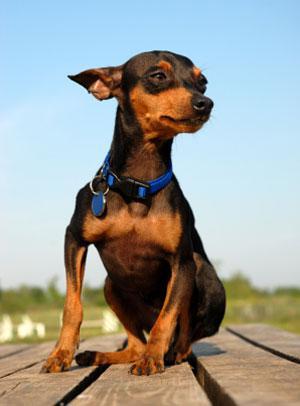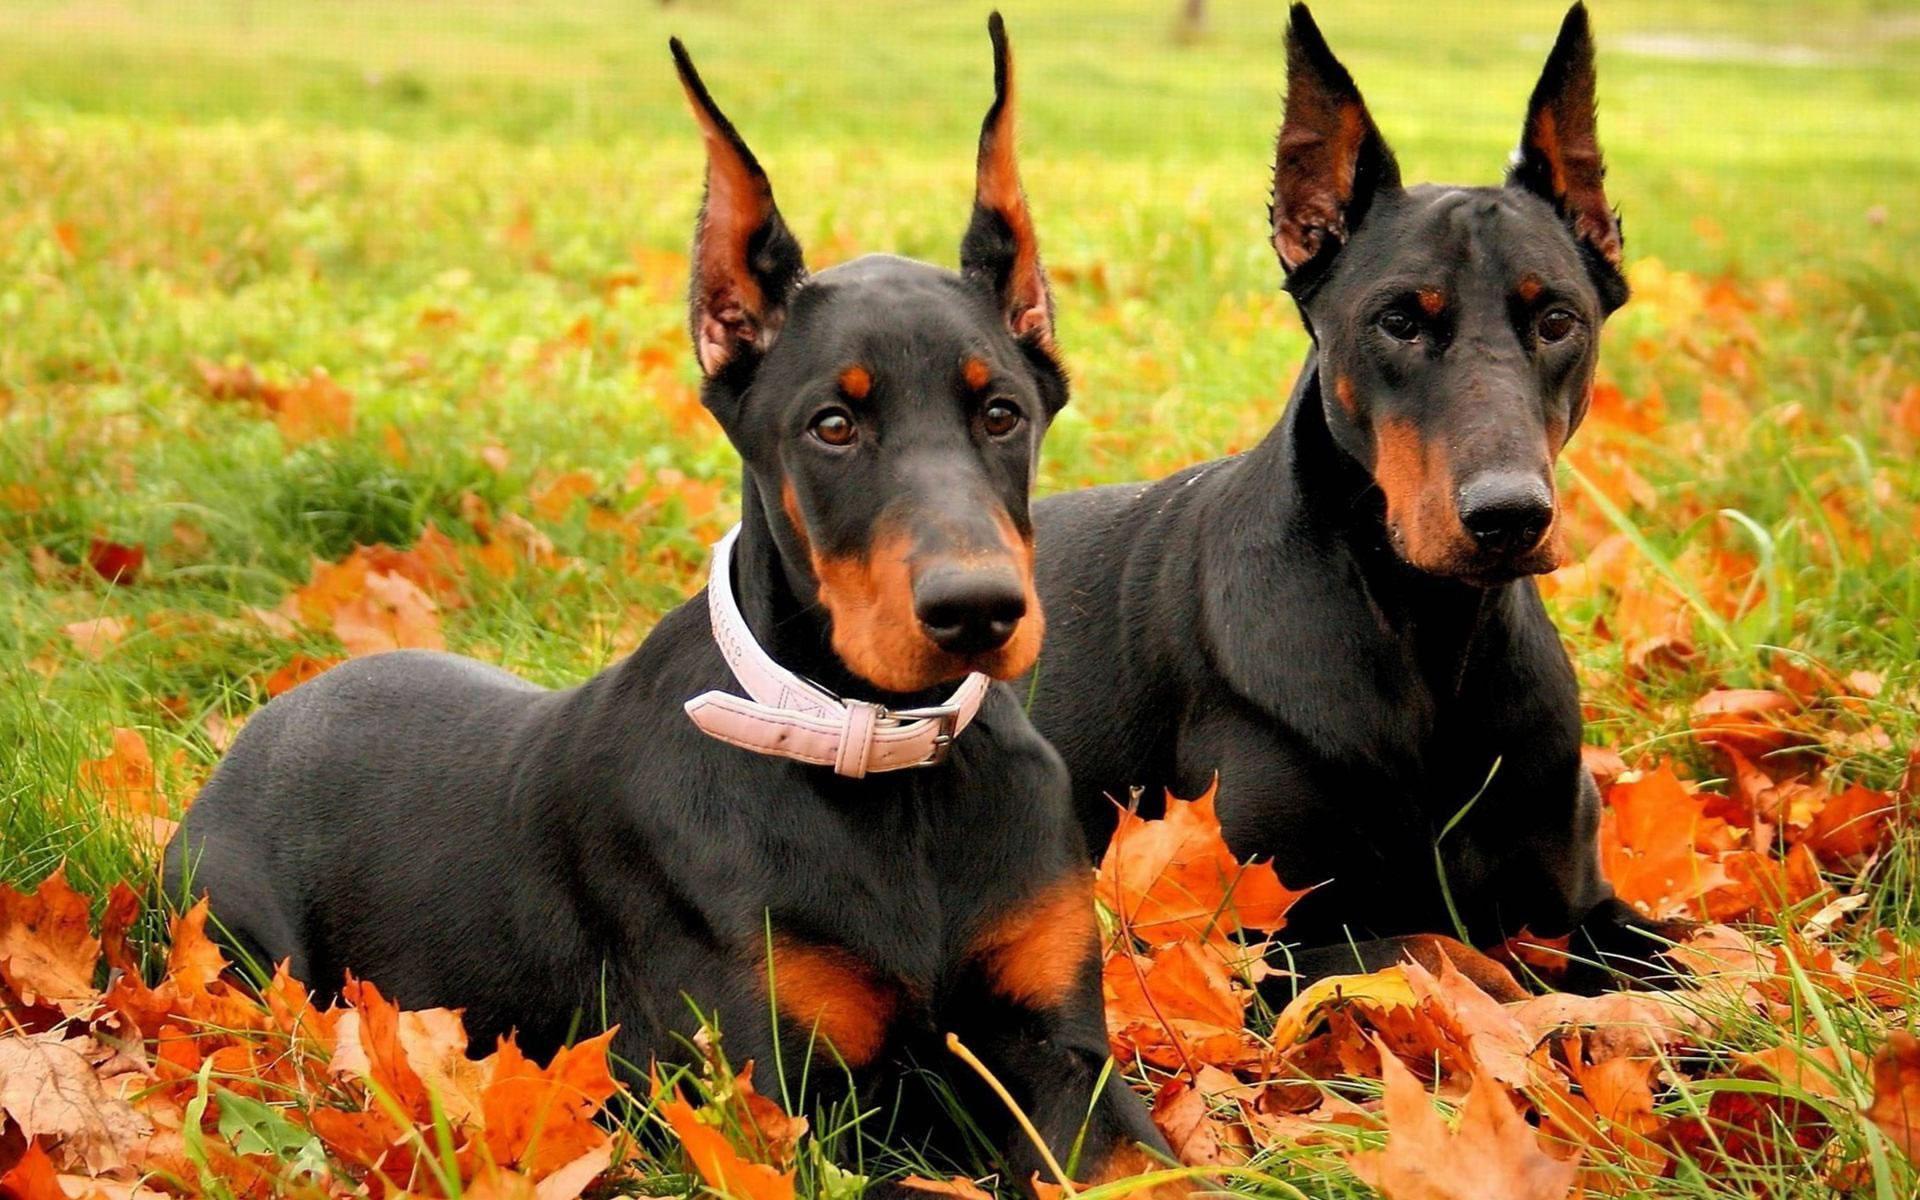The first image is the image on the left, the second image is the image on the right. Analyze the images presented: Is the assertion "The right image contains no more than one dog." valid? Answer yes or no. No. The first image is the image on the left, the second image is the image on the right. Examine the images to the left and right. Is the description "The right image includes two erect-eared dobermans reclining on fallen leaves, with their bodies turned forward." accurate? Answer yes or no. Yes. 